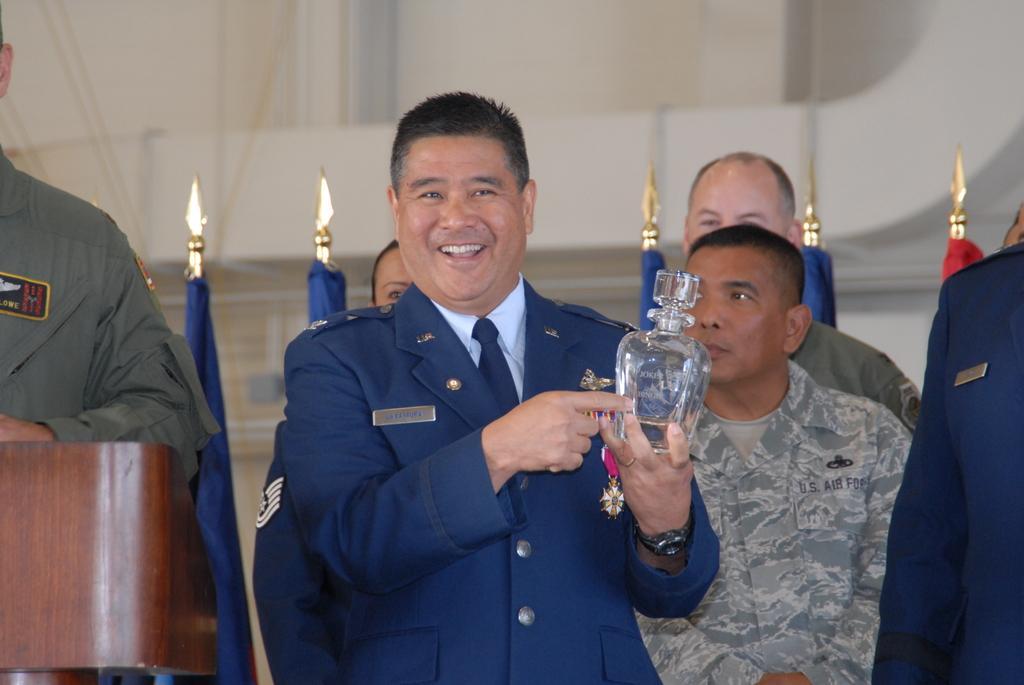In one or two sentences, can you explain what this image depicts? In this image I can see the group of people with different color dresses. I can see few people with the uniforms. One person is holding the glass. To the left there is a podium. In the background I can see the flags and the wall. 